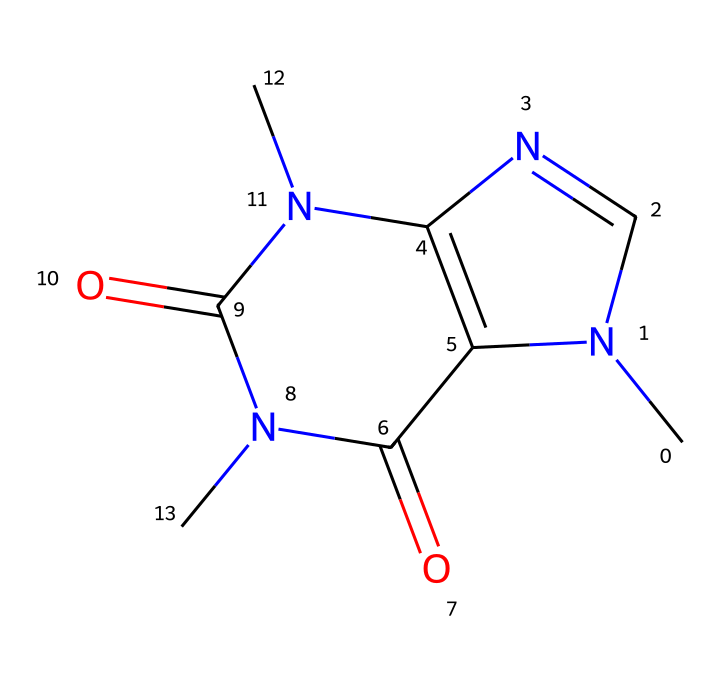What is the molecular formula of caffeine? By analyzing the SMILES representation, we can count the number of each type of atom present. The structure contains 8 carbon (C) atoms, 10 hydrogen (H) atoms, 4 nitrogen (N) atoms, and 2 oxygen (O) atoms, giving the molecular formula as C8H10N4O2.
Answer: C8H10N4O2 How many rings are present in the caffeine structure? The SMILES representation indicates that there are two fused rings in the structure (as suggested by the presence of 'N1' and 'C2'), which reveals a bicyclic system.
Answer: 2 Which atoms are primarily responsible for caffeine's stimulant effect? The presence of nitrogen atoms in the structure is crucial, particularly because they are part of the heterocyclic rings which contribute to the psychoactive properties of caffeine.
Answer: Nitrogen What type of chemical bonding primarily occurs in caffeine? In the chemical structure of caffeine, the predominant types of bonds are covalent bonds, shown by connections between atoms, particularly between carbon and nitrogen.
Answer: Covalent What is the total number of nitrogen atoms in caffeine? The SMILES format indicates four nitrogen atoms present in different parts of the structure, contributing to its properties as a stimulant.
Answer: 4 What functional groups are present in the caffeine structure? In examining the structure, we identify the carbonyl groups (C=O) and amine groups (N) that define caffeine's functionality as a medicinal compound.
Answer: Carbonyl and Amine What property does the carbonyl group in caffeine impart? The carbonyl groups contribute to the molecule's pharmacological properties and affect its solubility and reactivity in various biochemical contexts.
Answer: Pharmacological properties 